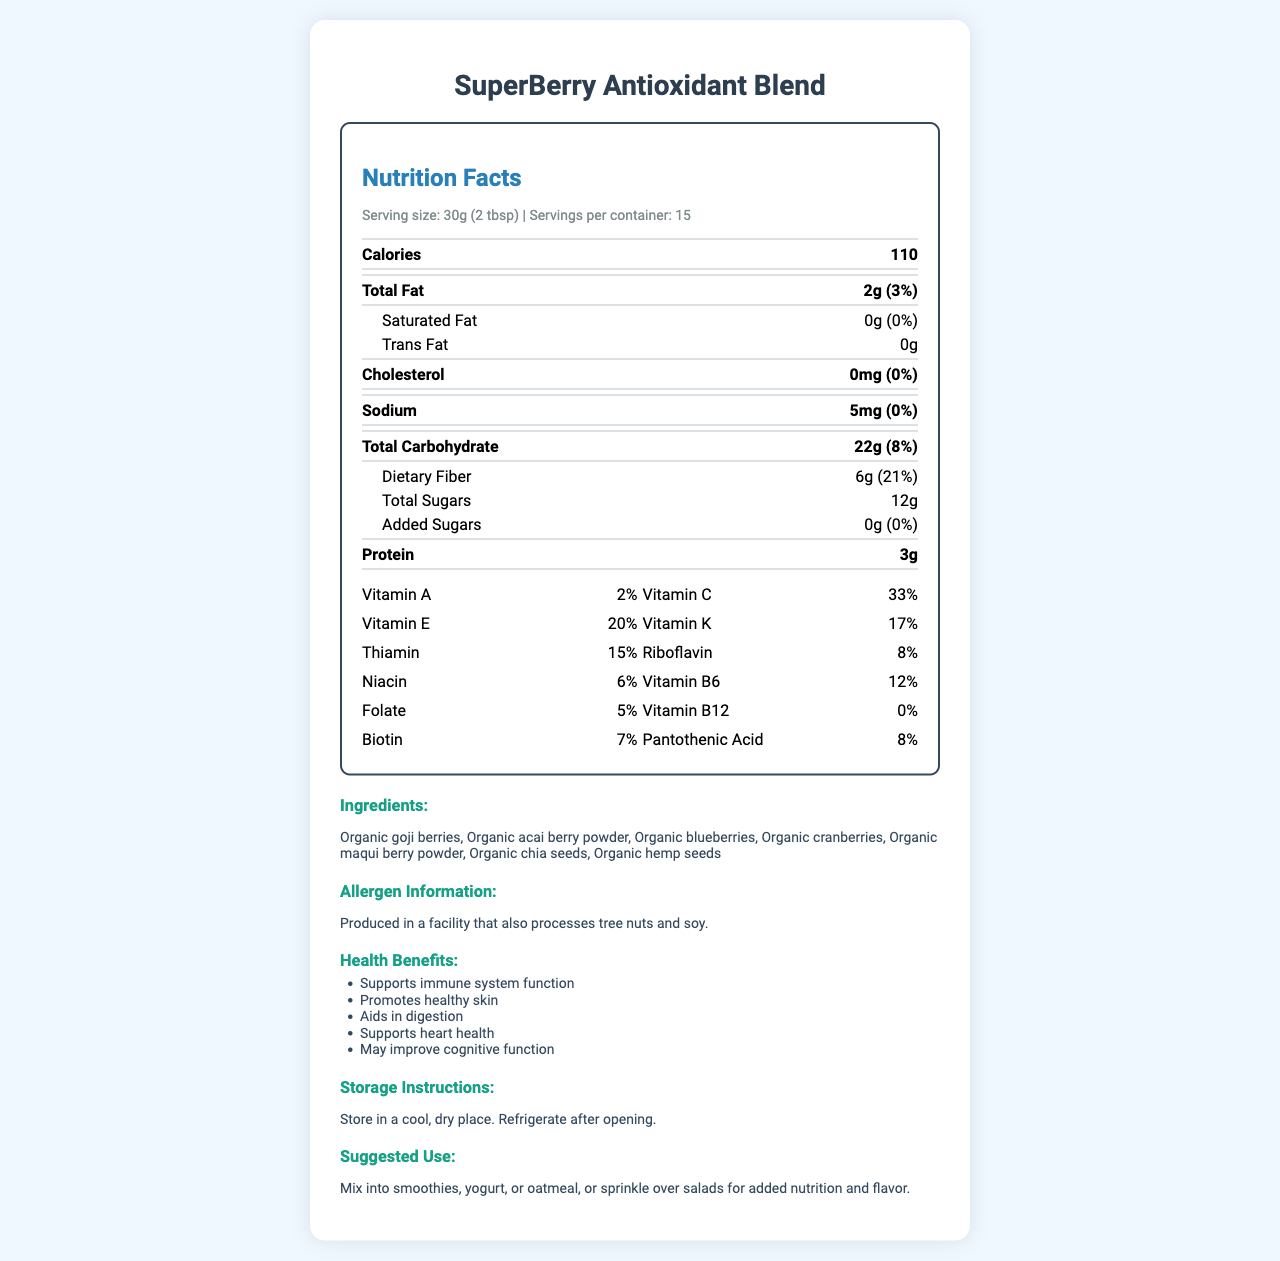what is the serving size of the SuperBerry Antioxidant Blend? The serving size is clearly mentioned under the "Serving size" label.
Answer: 30g (2 tbsp) how many servings are in the container? The "Servings per container" label specifies there are 15 servings.
Answer: 15 how many calories are in one serving? The number of calories per serving is shown next to "Calories".
Answer: 110 how much protein is in one serving? The amount of protein is displayed under the "Protein" label.
Answer: 3g what is the percentage of daily value for dietary fiber? The percentage for dietary fiber is given next to its amount.
Answer: 21% which vitamins are present in the blend? The document lists these vitamins in the vitamins section.
Answer: Vitamins A, C, E, and K along with Thiamin, Riboflavin, Niacin, Vitamin B6, Folate, Vitamin B12, Biotin, and Pantothenic Acid which of the following is not an ingredient in the blend? A. Organic goji berries B. Organic apple powder C. Organic blueberries D. Organic chia seeds Organic apple powder is not listed in the ingredients section.
Answer: B. Organic apple powder what is the main ingredient associated with antioxidant properties? A. Organic goji berries B. Organic acai berry powder C. Organic blueberries D. All of the above The document mentions multiple sources of antioxidants, including goji berries, acai berry powder, and others.
Answer: D. All of the above is there any cholesterol in the blend? The document mentions the amount of cholesterol as 0mg, along with a 0% daily value.
Answer: No describe the health benefits of the SuperBerry Antioxidant Blend. These benefits are listed under the health benefits section.
Answer: The health benefits include supporting immune system function, promoting healthy skin, aiding in digestion, supporting heart health, and potentially improving cognitive function. what is the origin of the blueberries used in the blend? The document does not specify the origin of the blueberries.
Answer: Cannot be determined can this product be mixed into smoothies and yogurt? The suggested use mentions mixing into smoothies, yogurt, or oatmeal, or sprinkling over salads.
Answer: Yes how much sugar is added? The label under "Added Sugars" specifies 0g (0% daily value).
Answer: 0g who should avoid this product due to allergens? The allergen information mentions that it is produced in a facility that also processes tree nuts and soy.
Answer: Those allergic to tree nuts and soy should avoid this product. 